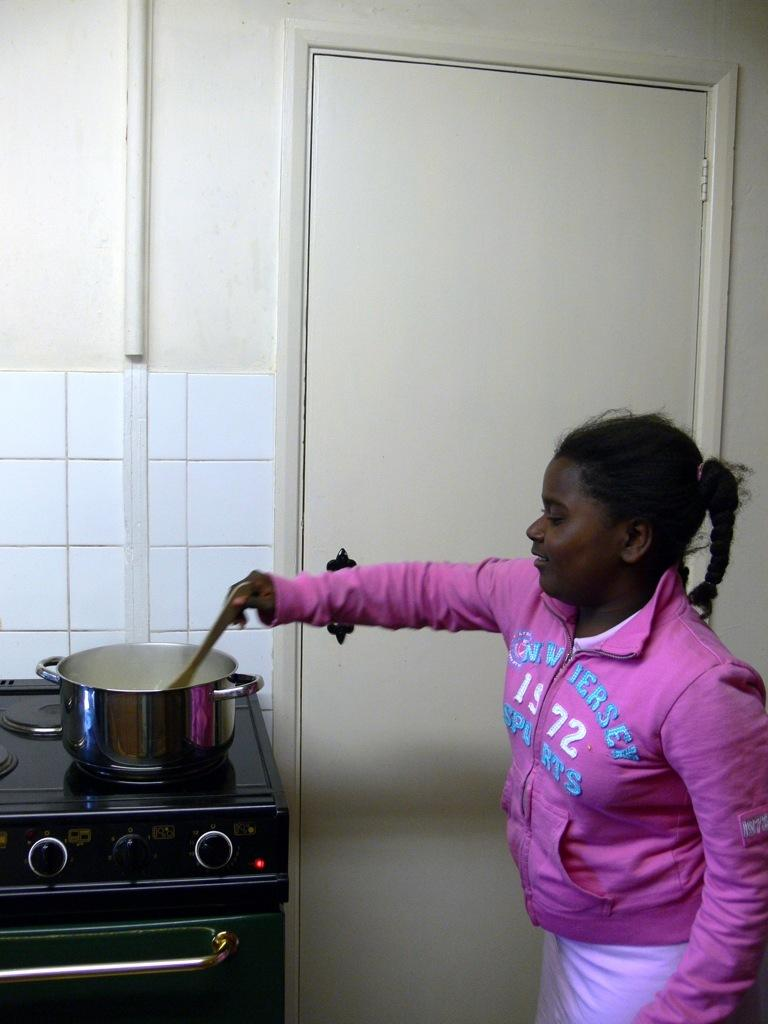<image>
Describe the image concisely. a little girl stirring a pot in a  pink sweater that says 'new jersey' 